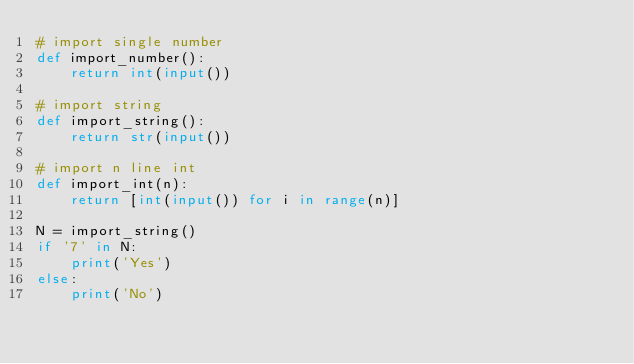<code> <loc_0><loc_0><loc_500><loc_500><_Python_># import single number
def import_number():
    return int(input())

# import string
def import_string():
    return str(input())

# import n line int
def import_int(n):
    return [int(input()) for i in range(n)]

N = import_string()
if '7' in N:
    print('Yes')
else:
    print('No')</code> 